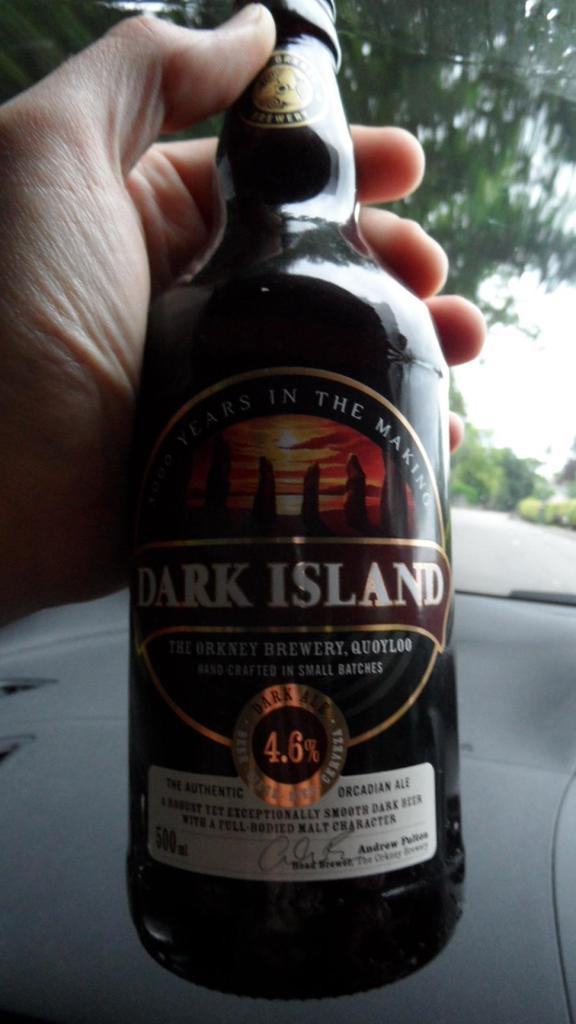Provide a one-sentence caption for the provided image. A black bottle of Dark Island Orcadian Ale. 